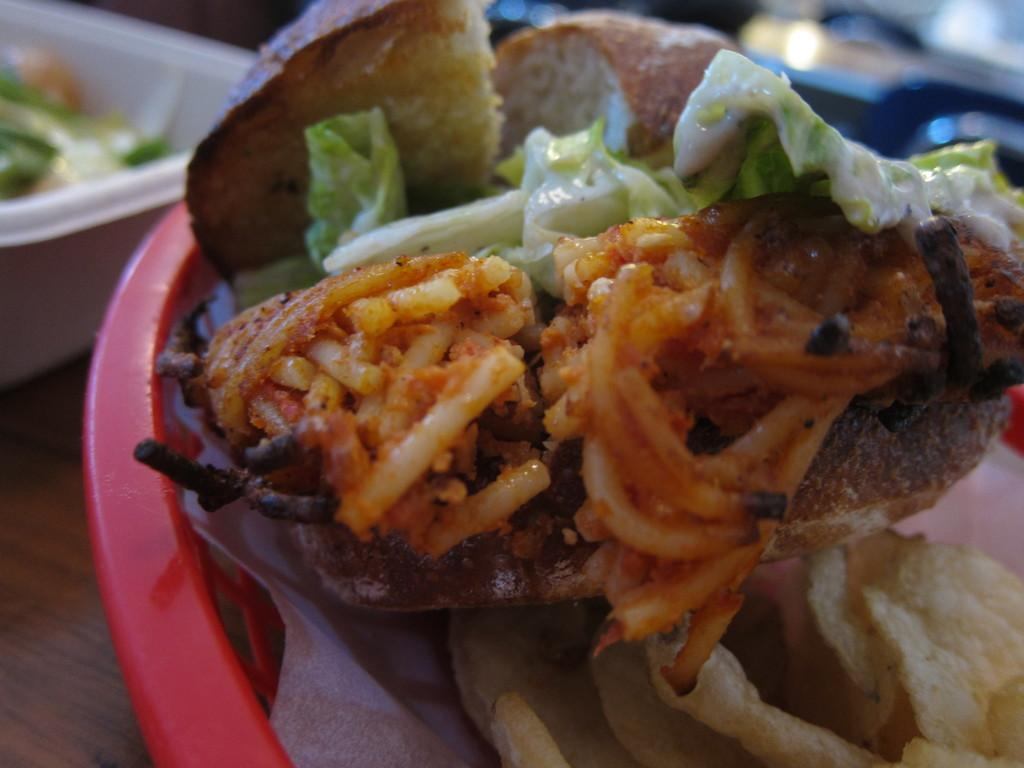What objects are present on the wooden surface in the image? There are bowls with food on a wooden surface in the image. Can you describe the background of the image? The background of the image is blurred. How many rabbits can be seen in the image? There are no rabbits present in the image. What color is the prison in the image? There is no prison present in the image. 